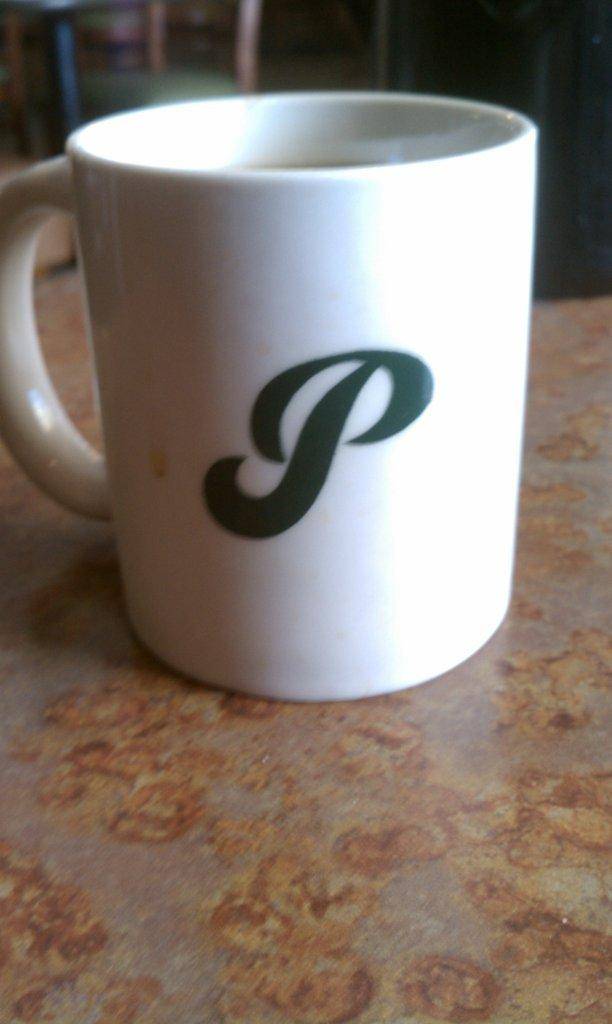What type of furniture is present in the image? There is a table in the image. What object is placed on the table? There is a white color cup on the table. Can you describe any other furniture in the image? There is a chair in the background of the image. What verse is written on the cup in the image? There is no verse written on the cup in the image; it is a plain white color cup. 